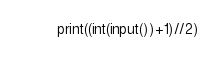<code> <loc_0><loc_0><loc_500><loc_500><_Python_>print((int(input())+1)//2)</code> 